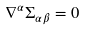Convert formula to latex. <formula><loc_0><loc_0><loc_500><loc_500>\nabla ^ { \alpha } \Sigma _ { \alpha \beta } = 0</formula> 